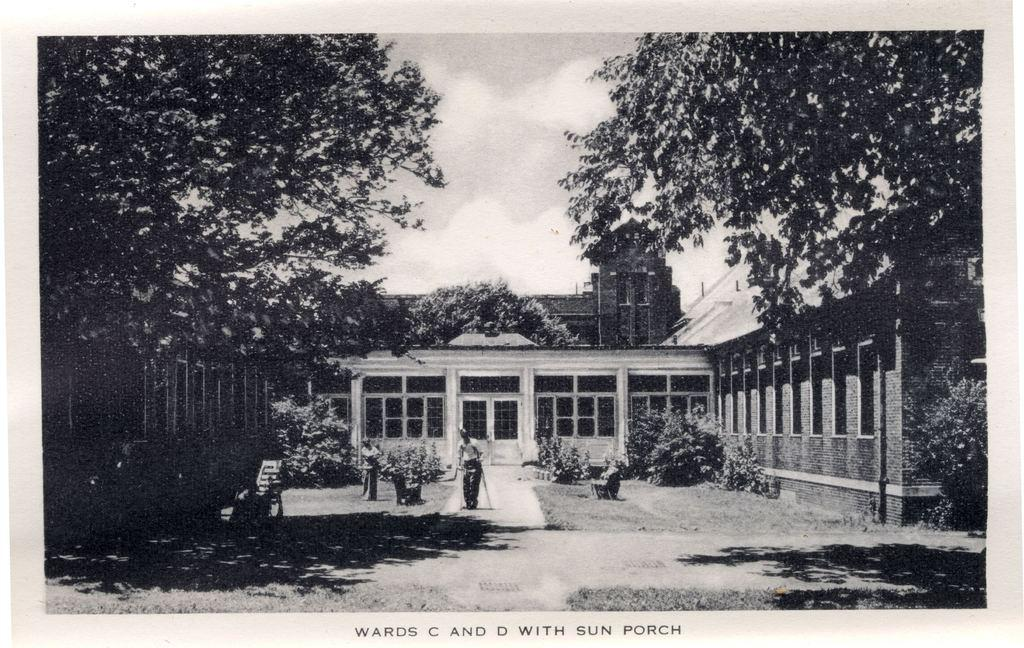<image>
Share a concise interpretation of the image provided. Wards C and D with sun porch picture that is black and white 